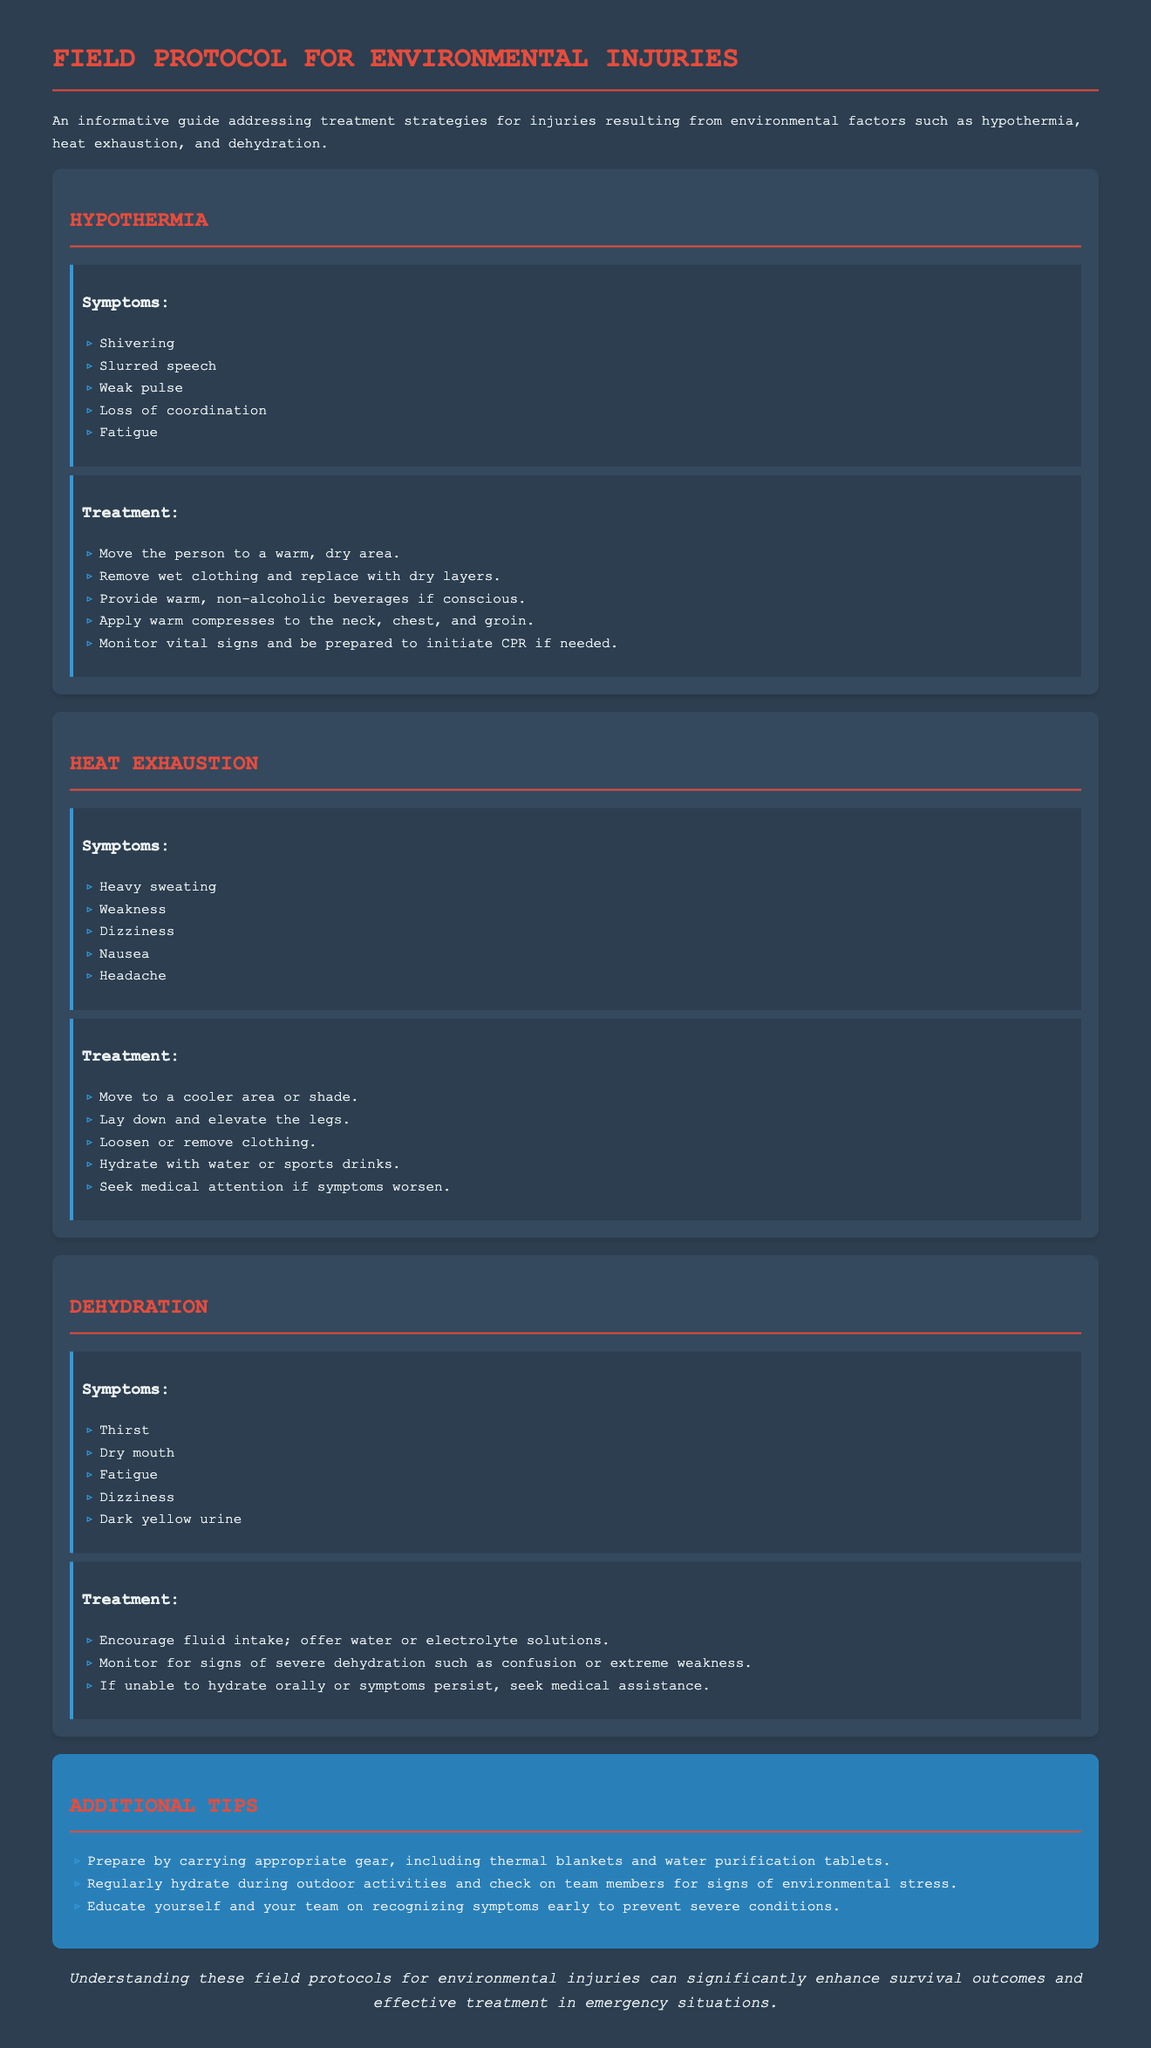What are the symptoms of hypothermia? The symptoms are listed in the document under the hypothermia section.
Answer: Shivering, Slurred speech, Weak pulse, Loss of coordination, Fatigue What is one recommended treatment for heat exhaustion? The treatment options for heat exhaustion are detailed in the heat exhaustion section of the document.
Answer: Move to a cooler area or shade What symptom is associated with dehydration? Symptoms of dehydration are enumerated in the dehydration section.
Answer: Thirst How many symptoms are listed for heat exhaustion? The document presents a specific number of symptoms for heat exhaustion under the corresponding heading.
Answer: Five What should you monitor for during dehydration treatment? The document specifies what signs to monitor while treating dehydration.
Answer: Signs of severe dehydration What color is associated with dark yellow urine in dehydration? The document labels the specific symptom related to urine color in dehydration.
Answer: Dark yellow What is emphasized in the additional tips section? The additional tips section contains key advice for preparation and awareness.
Answer: Carrying appropriate gear How should you hydrate during outdoor activities? The document advises on hydration methods during activities in the tips section.
Answer: Regularly hydrate What is a key symptom checklist for hypothermia? The symptom checklist is clearly outlined under the hypothermia section of the document.
Answer: Shivering, Slurred speech, Weak pulse, Loss of coordination, Fatigue 